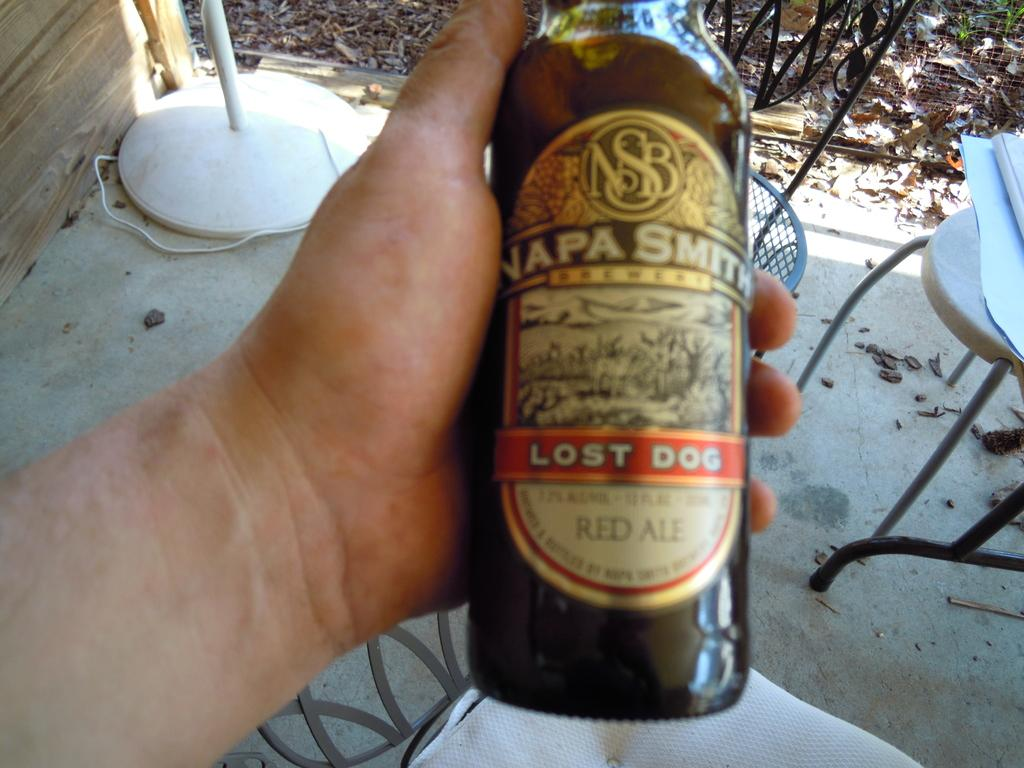<image>
Render a clear and concise summary of the photo. A bottle of Lost Dog beer is being held by someone on an outdoor patio. 